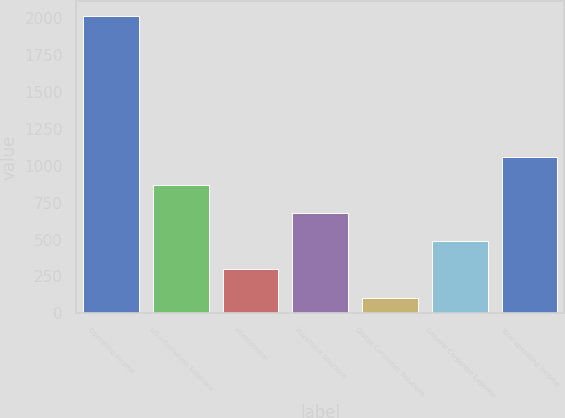<chart> <loc_0><loc_0><loc_500><loc_500><bar_chart><fcel>Operating income<fcel>US Information Solutions<fcel>International<fcel>Workforce Solutions<fcel>Global Consumer Solutions<fcel>General Corporate Expense<fcel>Total operating income<nl><fcel>2017<fcel>870.52<fcel>297.28<fcel>679.44<fcel>106.2<fcel>488.36<fcel>1061.6<nl></chart> 